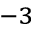<formula> <loc_0><loc_0><loc_500><loc_500>^ { - 3 }</formula> 